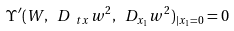<formula> <loc_0><loc_0><loc_500><loc_500>\Upsilon ^ { \prime } ( W , \ D _ { \ t x } w ^ { 2 } , \ D _ { x _ { 1 } } w ^ { 2 } ) _ { | x _ { 1 } = 0 } = 0</formula> 